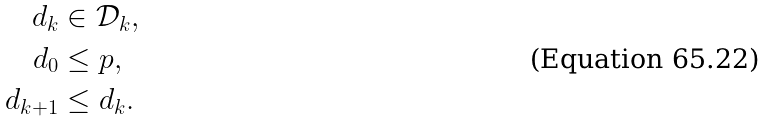<formula> <loc_0><loc_0><loc_500><loc_500>d _ { k } & \in \mathcal { D } _ { k } , \\ d _ { 0 } & \leq p , \\ d _ { k + 1 } & \leq d _ { k } .</formula> 